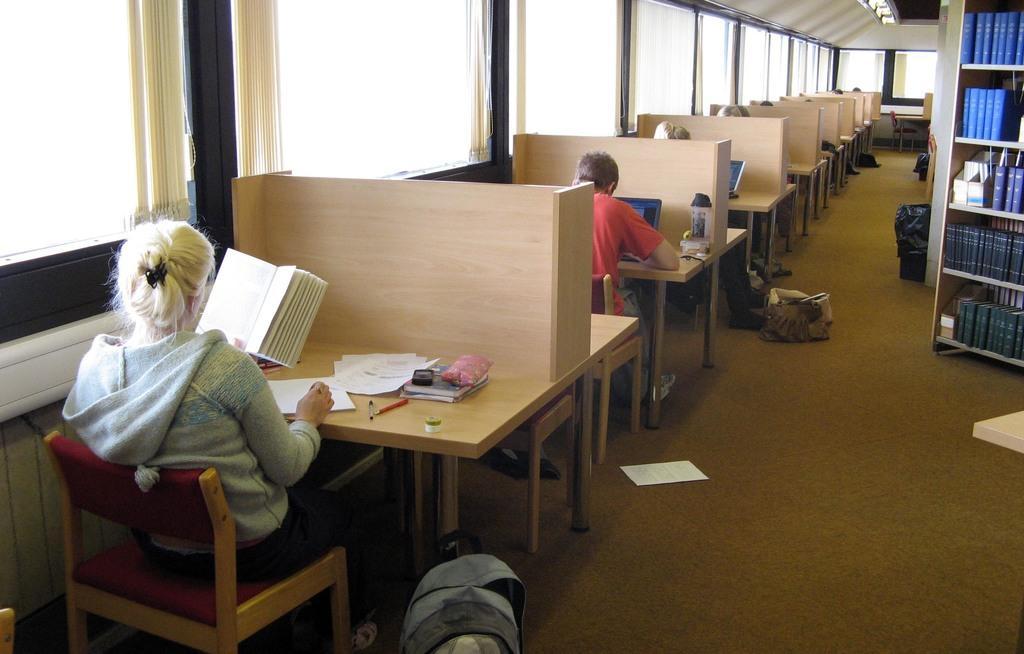How would you summarize this image in a sentence or two? On the left a woman is sitting on the chair and reading in the right there are bookshelves. 